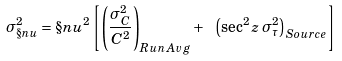Convert formula to latex. <formula><loc_0><loc_0><loc_500><loc_500>\sigma _ { \S n u } ^ { 2 } = \S n u ^ { 2 } \left [ \left ( \frac { \sigma _ { C } ^ { 2 } } { C ^ { 2 } } \right ) _ { R u n \, A v g } + \ \left ( \sec ^ { 2 } z \, \sigma _ { \tau } ^ { 2 } \right ) _ { S o u r c e } \right ]</formula> 